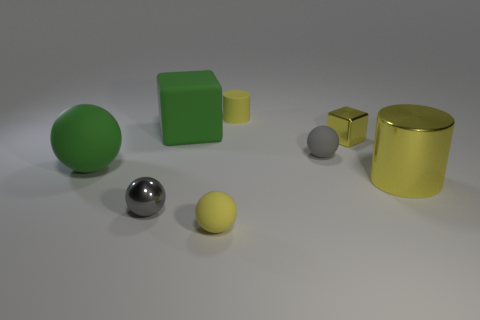There is a matte thing that is the same color as the rubber block; what is its shape?
Make the answer very short. Sphere. There is a yellow metal thing that is to the right of the small metallic block; does it have the same size as the yellow cylinder that is behind the yellow metal cylinder?
Make the answer very short. No. What number of objects are small matte blocks or tiny things that are in front of the green ball?
Give a very brief answer. 2. The metallic block is what color?
Keep it short and to the point. Yellow. The large yellow cylinder that is in front of the object to the left of the shiny thing that is in front of the yellow metallic cylinder is made of what material?
Provide a short and direct response. Metal. What is the size of the cylinder that is the same material as the large green sphere?
Ensure brevity in your answer.  Small. Is there a big rubber block that has the same color as the tiny cube?
Provide a succinct answer. No. There is a matte cube; does it have the same size as the yellow shiny thing that is on the right side of the tiny block?
Keep it short and to the point. Yes. What number of matte things are on the left side of the cube to the left of the yellow cylinder that is behind the small gray matte sphere?
Provide a succinct answer. 1. The metal block that is the same color as the rubber cylinder is what size?
Keep it short and to the point. Small. 